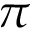<formula> <loc_0><loc_0><loc_500><loc_500>\pi</formula> 